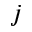<formula> <loc_0><loc_0><loc_500><loc_500>j</formula> 